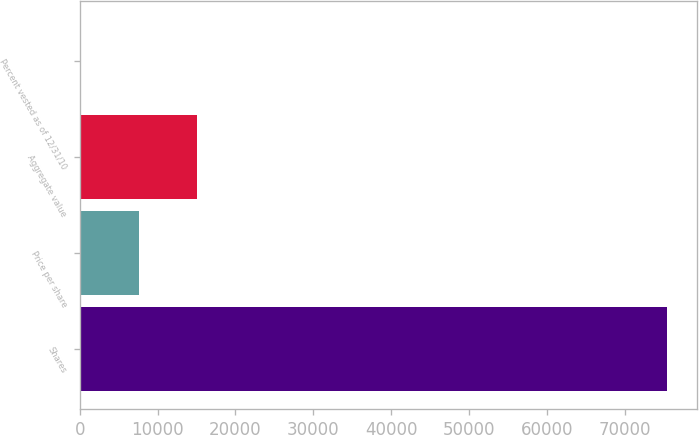Convert chart. <chart><loc_0><loc_0><loc_500><loc_500><bar_chart><fcel>Shares<fcel>Price per share<fcel>Aggregate value<fcel>Percent vested as of 12/31/10<nl><fcel>75500<fcel>7568<fcel>15116<fcel>20<nl></chart> 